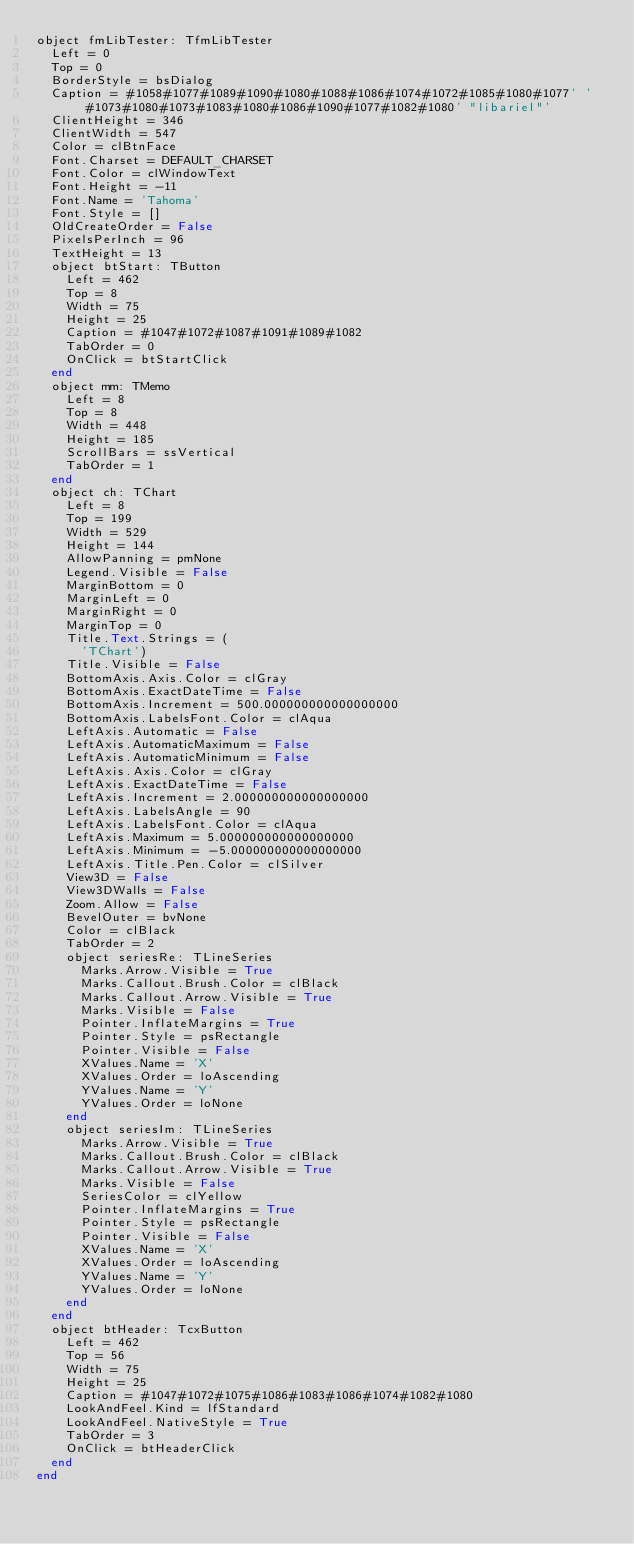Convert code to text. <code><loc_0><loc_0><loc_500><loc_500><_Pascal_>object fmLibTester: TfmLibTester
  Left = 0
  Top = 0
  BorderStyle = bsDialog
  Caption = #1058#1077#1089#1090#1080#1088#1086#1074#1072#1085#1080#1077' '#1073#1080#1073#1083#1080#1086#1090#1077#1082#1080' "libariel"'
  ClientHeight = 346
  ClientWidth = 547
  Color = clBtnFace
  Font.Charset = DEFAULT_CHARSET
  Font.Color = clWindowText
  Font.Height = -11
  Font.Name = 'Tahoma'
  Font.Style = []
  OldCreateOrder = False
  PixelsPerInch = 96
  TextHeight = 13
  object btStart: TButton
    Left = 462
    Top = 8
    Width = 75
    Height = 25
    Caption = #1047#1072#1087#1091#1089#1082
    TabOrder = 0
    OnClick = btStartClick
  end
  object mm: TMemo
    Left = 8
    Top = 8
    Width = 448
    Height = 185
    ScrollBars = ssVertical
    TabOrder = 1
  end
  object ch: TChart
    Left = 8
    Top = 199
    Width = 529
    Height = 144
    AllowPanning = pmNone
    Legend.Visible = False
    MarginBottom = 0
    MarginLeft = 0
    MarginRight = 0
    MarginTop = 0
    Title.Text.Strings = (
      'TChart')
    Title.Visible = False
    BottomAxis.Axis.Color = clGray
    BottomAxis.ExactDateTime = False
    BottomAxis.Increment = 500.000000000000000000
    BottomAxis.LabelsFont.Color = clAqua
    LeftAxis.Automatic = False
    LeftAxis.AutomaticMaximum = False
    LeftAxis.AutomaticMinimum = False
    LeftAxis.Axis.Color = clGray
    LeftAxis.ExactDateTime = False
    LeftAxis.Increment = 2.000000000000000000
    LeftAxis.LabelsAngle = 90
    LeftAxis.LabelsFont.Color = clAqua
    LeftAxis.Maximum = 5.000000000000000000
    LeftAxis.Minimum = -5.000000000000000000
    LeftAxis.Title.Pen.Color = clSilver
    View3D = False
    View3DWalls = False
    Zoom.Allow = False
    BevelOuter = bvNone
    Color = clBlack
    TabOrder = 2
    object seriesRe: TLineSeries
      Marks.Arrow.Visible = True
      Marks.Callout.Brush.Color = clBlack
      Marks.Callout.Arrow.Visible = True
      Marks.Visible = False
      Pointer.InflateMargins = True
      Pointer.Style = psRectangle
      Pointer.Visible = False
      XValues.Name = 'X'
      XValues.Order = loAscending
      YValues.Name = 'Y'
      YValues.Order = loNone
    end
    object seriesIm: TLineSeries
      Marks.Arrow.Visible = True
      Marks.Callout.Brush.Color = clBlack
      Marks.Callout.Arrow.Visible = True
      Marks.Visible = False
      SeriesColor = clYellow
      Pointer.InflateMargins = True
      Pointer.Style = psRectangle
      Pointer.Visible = False
      XValues.Name = 'X'
      XValues.Order = loAscending
      YValues.Name = 'Y'
      YValues.Order = loNone
    end
  end
  object btHeader: TcxButton
    Left = 462
    Top = 56
    Width = 75
    Height = 25
    Caption = #1047#1072#1075#1086#1083#1086#1074#1082#1080
    LookAndFeel.Kind = lfStandard
    LookAndFeel.NativeStyle = True
    TabOrder = 3
    OnClick = btHeaderClick
  end
end
</code> 